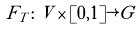<formula> <loc_0><loc_0><loc_500><loc_500>F _ { T } \colon V \times [ 0 , 1 ] \rightarrow G</formula> 